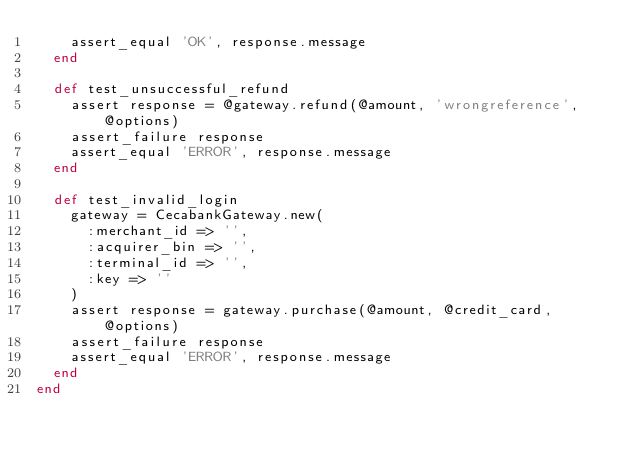<code> <loc_0><loc_0><loc_500><loc_500><_Ruby_>    assert_equal 'OK', response.message
  end

  def test_unsuccessful_refund
    assert response = @gateway.refund(@amount, 'wrongreference', @options)
    assert_failure response
    assert_equal 'ERROR', response.message
  end

  def test_invalid_login
    gateway = CecabankGateway.new(
      :merchant_id => '',
      :acquirer_bin => '',
      :terminal_id => '',
      :key => ''
    )
    assert response = gateway.purchase(@amount, @credit_card, @options)
    assert_failure response
    assert_equal 'ERROR', response.message
  end
end
</code> 